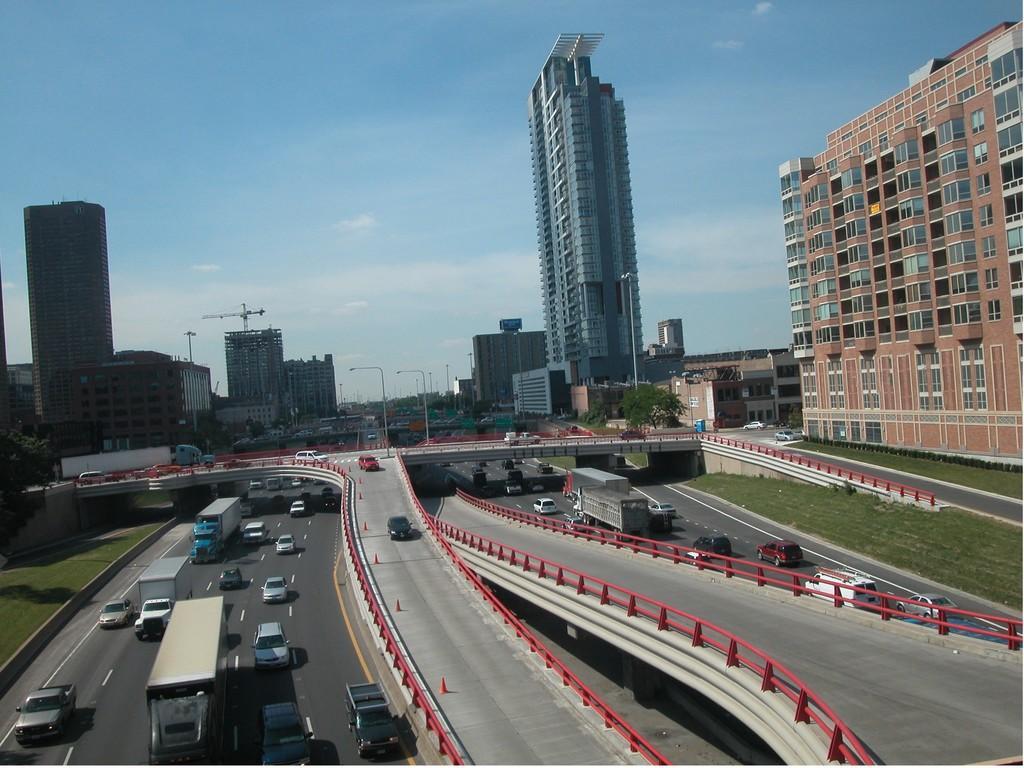Could you give a brief overview of what you see in this image? In this image there are roads in the middle. On the roads there are vehicles. In the background there are tall buildings. At the top there is the sky. In the background there is a building under construction. On the right side there is a ground on which there is grass. 